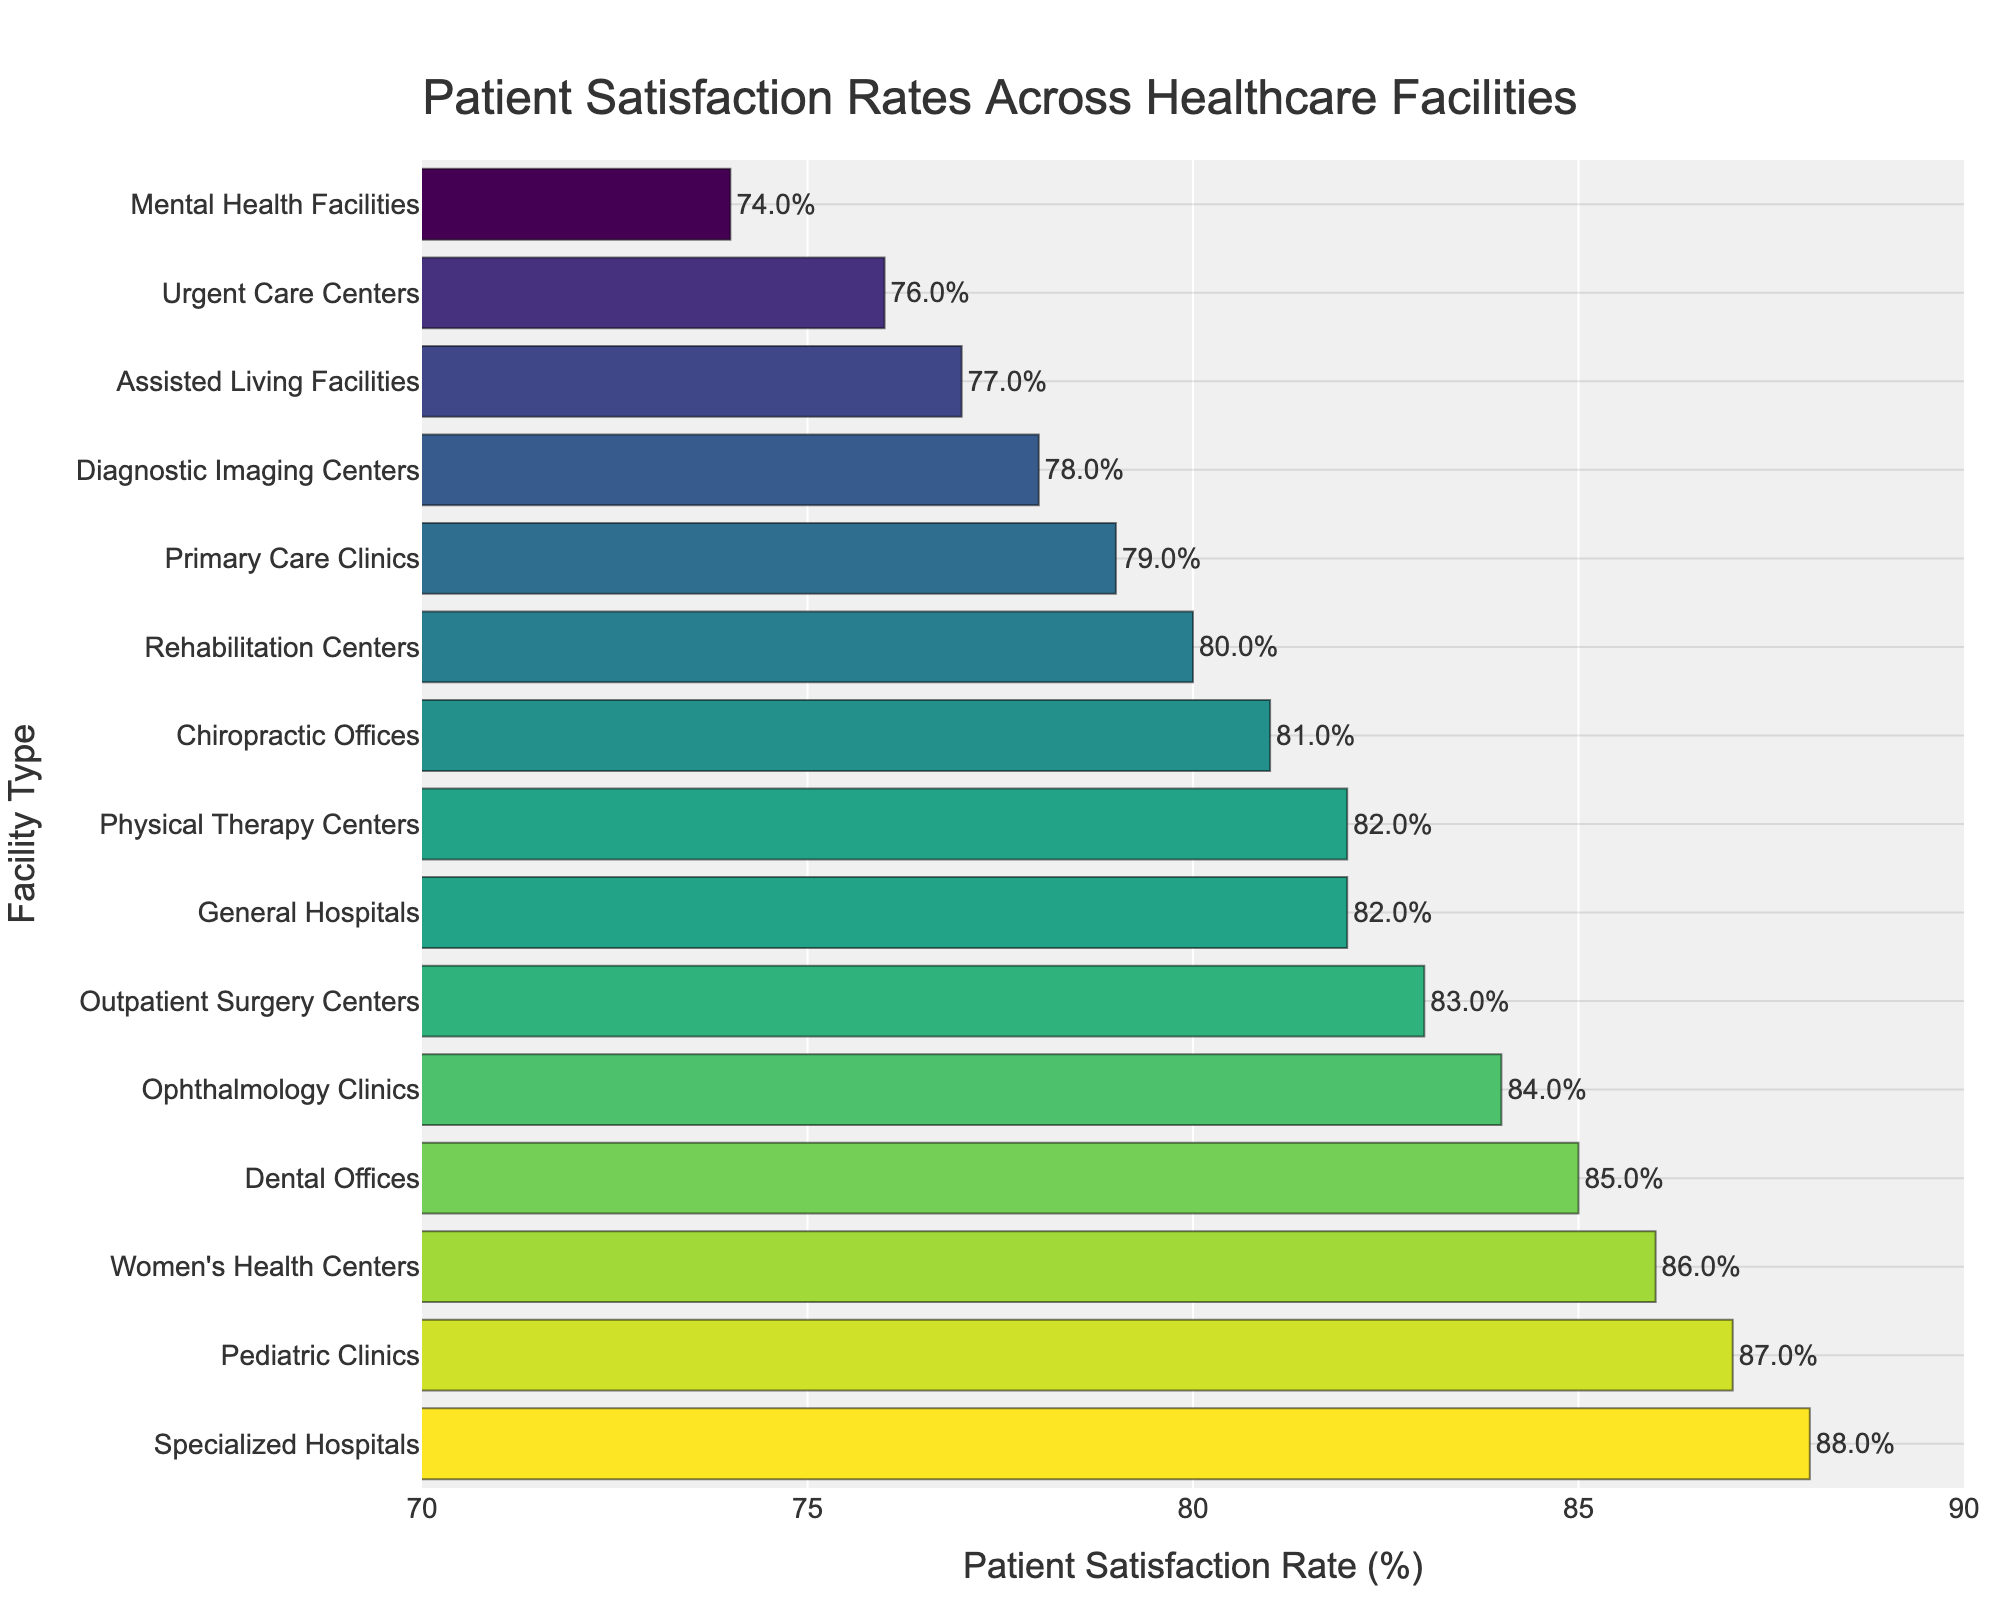Which healthcare facility type has the highest patient satisfaction rate? We look at the bar chart and identify the facility type with the longest bar. The longest bar corresponds to Specialized Hospitals with a satisfaction rate of 88%.
Answer: Specialized Hospitals Which healthcare facility type has the lowest patient satisfaction rate? By identifying the shortest bar on the chart, we can determine that Mental Health Facilities have the lowest patient satisfaction rate at 74%.
Answer: Mental Health Facilities What is the difference in patient satisfaction rates between Dental Offices and Urgent Care Centers? Dental Offices have a satisfaction rate of 85%, and Urgent Care Centers have a satisfaction rate of 76%. The difference is calculated as 85% - 76% = 9%.
Answer: 9% Which healthcare facility type has a higher patient satisfaction rate, Women's Health Centers or Pediatric Clinics? We compare the bars for Women's Health Centers and Pediatric Clinics. Women's Health Centers have a satisfaction rate of 86%, and Pediatric Clinics have a satisfaction rate of 87%. Thus, Pediatric Clinics have a higher rate.
Answer: Pediatric Clinics What is the average patient satisfaction rate across all facility types? Summing up all satisfaction rates: 82 + 88 + 76 + 79 + 85 + 83 + 74 + 80 + 87 + 86 + 81 + 84 + 82 + 78 + 77 = 1232. Dividing by the number of facility types (15) gives us the average: 1232 / 15 ≈ 82.13%.
Answer: 82.13% What is the total range of patient satisfaction rates represented in the chart? The range is found by subtracting the lowest satisfaction rate (Mental Health Facilities at 74%) from the highest (Specialized Hospitals at 88%). Thus, the range is 88% - 74% = 14%.
Answer: 14% Which facility type has a patient satisfaction rate that falls exactly between Primary Care Clinics and Rehabilitation Centers? Primary Care Clinics have a satisfaction rate of 79% and Rehabilitation Centers have a satisfaction rate of 80%. The facility type with a satisfaction rate between these two would be Chiropractic Offices at 81%.
Answer: Chiropractic Offices How many facility types have a patient satisfaction rate above 80%? We count the number of bars that correspond to satisfaction rates above 80%: General Hospitals, Specialized Hospitals, Dental Offices, Outpatient Surgery Centers, Pediatric Clinics, Women's Health Centers, Chiropractic Offices, and Ophthalmology Clinics. That's 8 facility types.
Answer: 8 Which facility types have patient satisfaction rates that are exactly the same? We look for facility types with bars of equal length. General Hospitals and Physical Therapy Centers both have a satisfaction rate of 82%.
Answer: General Hospitals and Physical Therapy Centers What is the median patient satisfaction rate among all facility types? To find the median, we first order the satisfaction rates: 74, 76, 77, 78, 79, 80, 81, 82, 82, 83, 84, 85, 86, 87, 88. The median is the middle value (8th value) in this odd-numbered list, which is 82%.
Answer: 82% 